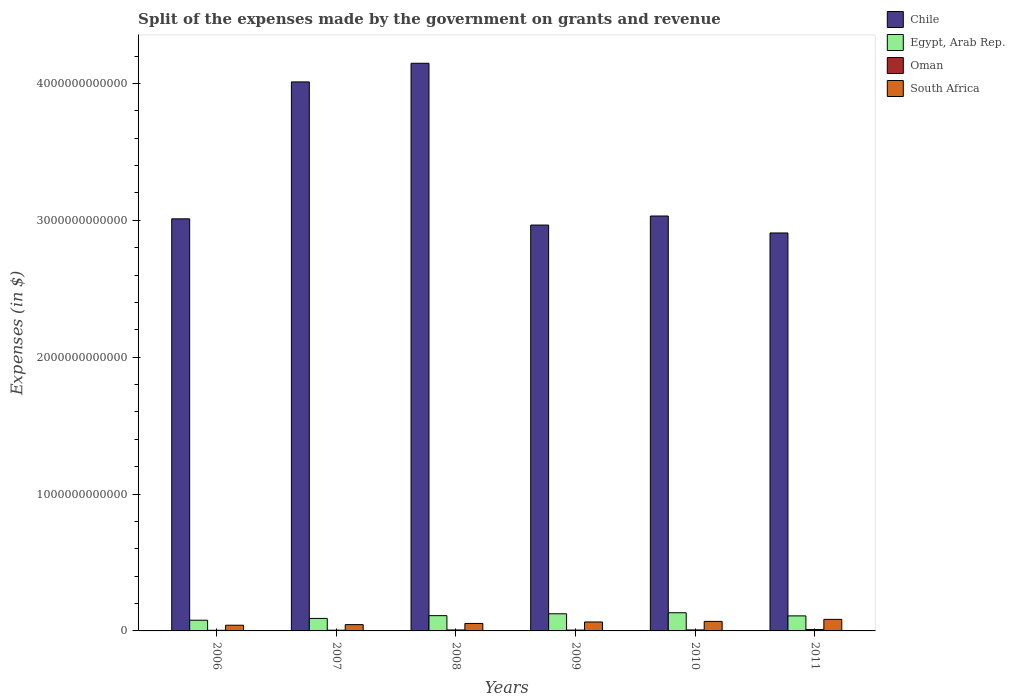How many different coloured bars are there?
Provide a succinct answer. 4. Are the number of bars per tick equal to the number of legend labels?
Provide a short and direct response. Yes. How many bars are there on the 1st tick from the left?
Provide a succinct answer. 4. How many bars are there on the 4th tick from the right?
Ensure brevity in your answer.  4. What is the label of the 2nd group of bars from the left?
Your answer should be very brief. 2007. In how many cases, is the number of bars for a given year not equal to the number of legend labels?
Keep it short and to the point. 0. What is the expenses made by the government on grants and revenue in Oman in 2008?
Offer a very short reply. 7.02e+09. Across all years, what is the maximum expenses made by the government on grants and revenue in Chile?
Ensure brevity in your answer.  4.15e+12. Across all years, what is the minimum expenses made by the government on grants and revenue in South Africa?
Provide a short and direct response. 4.16e+1. In which year was the expenses made by the government on grants and revenue in Chile maximum?
Give a very brief answer. 2008. In which year was the expenses made by the government on grants and revenue in Egypt, Arab Rep. minimum?
Provide a succinct answer. 2006. What is the total expenses made by the government on grants and revenue in Oman in the graph?
Offer a very short reply. 4.05e+1. What is the difference between the expenses made by the government on grants and revenue in South Africa in 2007 and that in 2010?
Provide a succinct answer. -2.36e+1. What is the difference between the expenses made by the government on grants and revenue in South Africa in 2008 and the expenses made by the government on grants and revenue in Egypt, Arab Rep. in 2011?
Your response must be concise. -5.53e+1. What is the average expenses made by the government on grants and revenue in Egypt, Arab Rep. per year?
Your answer should be very brief. 1.08e+11. In the year 2006, what is the difference between the expenses made by the government on grants and revenue in Egypt, Arab Rep. and expenses made by the government on grants and revenue in South Africa?
Offer a terse response. 3.66e+1. In how many years, is the expenses made by the government on grants and revenue in Egypt, Arab Rep. greater than 3600000000000 $?
Offer a terse response. 0. What is the ratio of the expenses made by the government on grants and revenue in Chile in 2010 to that in 2011?
Your response must be concise. 1.04. Is the expenses made by the government on grants and revenue in Chile in 2007 less than that in 2011?
Your answer should be compact. No. Is the difference between the expenses made by the government on grants and revenue in Egypt, Arab Rep. in 2010 and 2011 greater than the difference between the expenses made by the government on grants and revenue in South Africa in 2010 and 2011?
Keep it short and to the point. Yes. What is the difference between the highest and the second highest expenses made by the government on grants and revenue in Chile?
Your answer should be very brief. 1.36e+11. What is the difference between the highest and the lowest expenses made by the government on grants and revenue in South Africa?
Your response must be concise. 4.28e+1. Is the sum of the expenses made by the government on grants and revenue in Oman in 2008 and 2011 greater than the maximum expenses made by the government on grants and revenue in South Africa across all years?
Ensure brevity in your answer.  No. What does the 3rd bar from the left in 2007 represents?
Provide a short and direct response. Oman. Is it the case that in every year, the sum of the expenses made by the government on grants and revenue in South Africa and expenses made by the government on grants and revenue in Egypt, Arab Rep. is greater than the expenses made by the government on grants and revenue in Chile?
Give a very brief answer. No. How many bars are there?
Make the answer very short. 24. Are all the bars in the graph horizontal?
Provide a succinct answer. No. How many years are there in the graph?
Your answer should be very brief. 6. What is the difference between two consecutive major ticks on the Y-axis?
Make the answer very short. 1.00e+12. Are the values on the major ticks of Y-axis written in scientific E-notation?
Keep it short and to the point. No. Does the graph contain any zero values?
Ensure brevity in your answer.  No. Where does the legend appear in the graph?
Keep it short and to the point. Top right. How are the legend labels stacked?
Provide a short and direct response. Vertical. What is the title of the graph?
Provide a short and direct response. Split of the expenses made by the government on grants and revenue. What is the label or title of the X-axis?
Your answer should be very brief. Years. What is the label or title of the Y-axis?
Keep it short and to the point. Expenses (in $). What is the Expenses (in $) of Chile in 2006?
Provide a short and direct response. 3.01e+12. What is the Expenses (in $) in Egypt, Arab Rep. in 2006?
Keep it short and to the point. 7.82e+1. What is the Expenses (in $) of Oman in 2006?
Give a very brief answer. 4.63e+09. What is the Expenses (in $) in South Africa in 2006?
Your answer should be compact. 4.16e+1. What is the Expenses (in $) in Chile in 2007?
Provide a succinct answer. 4.01e+12. What is the Expenses (in $) in Egypt, Arab Rep. in 2007?
Provide a short and direct response. 9.13e+1. What is the Expenses (in $) in Oman in 2007?
Provide a succinct answer. 5.40e+09. What is the Expenses (in $) in South Africa in 2007?
Give a very brief answer. 4.60e+1. What is the Expenses (in $) in Chile in 2008?
Give a very brief answer. 4.15e+12. What is the Expenses (in $) of Egypt, Arab Rep. in 2008?
Ensure brevity in your answer.  1.12e+11. What is the Expenses (in $) in Oman in 2008?
Keep it short and to the point. 7.02e+09. What is the Expenses (in $) in South Africa in 2008?
Offer a terse response. 5.46e+1. What is the Expenses (in $) in Chile in 2009?
Make the answer very short. 2.97e+12. What is the Expenses (in $) of Egypt, Arab Rep. in 2009?
Your answer should be compact. 1.25e+11. What is the Expenses (in $) of Oman in 2009?
Your response must be concise. 6.14e+09. What is the Expenses (in $) in South Africa in 2009?
Make the answer very short. 6.53e+1. What is the Expenses (in $) of Chile in 2010?
Ensure brevity in your answer.  3.03e+12. What is the Expenses (in $) in Egypt, Arab Rep. in 2010?
Your answer should be very brief. 1.33e+11. What is the Expenses (in $) in Oman in 2010?
Make the answer very short. 7.31e+09. What is the Expenses (in $) in South Africa in 2010?
Provide a short and direct response. 6.96e+1. What is the Expenses (in $) in Chile in 2011?
Provide a succinct answer. 2.91e+12. What is the Expenses (in $) in Egypt, Arab Rep. in 2011?
Offer a terse response. 1.10e+11. What is the Expenses (in $) in Oman in 2011?
Make the answer very short. 9.99e+09. What is the Expenses (in $) in South Africa in 2011?
Offer a very short reply. 8.44e+1. Across all years, what is the maximum Expenses (in $) of Chile?
Offer a very short reply. 4.15e+12. Across all years, what is the maximum Expenses (in $) of Egypt, Arab Rep.?
Make the answer very short. 1.33e+11. Across all years, what is the maximum Expenses (in $) of Oman?
Offer a very short reply. 9.99e+09. Across all years, what is the maximum Expenses (in $) of South Africa?
Offer a very short reply. 8.44e+1. Across all years, what is the minimum Expenses (in $) in Chile?
Keep it short and to the point. 2.91e+12. Across all years, what is the minimum Expenses (in $) in Egypt, Arab Rep.?
Make the answer very short. 7.82e+1. Across all years, what is the minimum Expenses (in $) of Oman?
Give a very brief answer. 4.63e+09. Across all years, what is the minimum Expenses (in $) in South Africa?
Keep it short and to the point. 4.16e+1. What is the total Expenses (in $) of Chile in the graph?
Make the answer very short. 2.01e+13. What is the total Expenses (in $) of Egypt, Arab Rep. in the graph?
Provide a short and direct response. 6.49e+11. What is the total Expenses (in $) in Oman in the graph?
Give a very brief answer. 4.05e+1. What is the total Expenses (in $) of South Africa in the graph?
Your answer should be compact. 3.62e+11. What is the difference between the Expenses (in $) in Chile in 2006 and that in 2007?
Your answer should be very brief. -1.00e+12. What is the difference between the Expenses (in $) in Egypt, Arab Rep. in 2006 and that in 2007?
Your response must be concise. -1.32e+1. What is the difference between the Expenses (in $) in Oman in 2006 and that in 2007?
Make the answer very short. -7.66e+08. What is the difference between the Expenses (in $) of South Africa in 2006 and that in 2007?
Give a very brief answer. -4.43e+09. What is the difference between the Expenses (in $) of Chile in 2006 and that in 2008?
Give a very brief answer. -1.14e+12. What is the difference between the Expenses (in $) in Egypt, Arab Rep. in 2006 and that in 2008?
Your response must be concise. -3.35e+1. What is the difference between the Expenses (in $) of Oman in 2006 and that in 2008?
Your answer should be compact. -2.38e+09. What is the difference between the Expenses (in $) in South Africa in 2006 and that in 2008?
Your answer should be compact. -1.30e+1. What is the difference between the Expenses (in $) of Chile in 2006 and that in 2009?
Provide a short and direct response. 4.55e+1. What is the difference between the Expenses (in $) in Egypt, Arab Rep. in 2006 and that in 2009?
Your answer should be very brief. -4.72e+1. What is the difference between the Expenses (in $) of Oman in 2006 and that in 2009?
Your answer should be compact. -1.50e+09. What is the difference between the Expenses (in $) of South Africa in 2006 and that in 2009?
Your response must be concise. -2.37e+1. What is the difference between the Expenses (in $) in Chile in 2006 and that in 2010?
Your response must be concise. -2.07e+1. What is the difference between the Expenses (in $) in Egypt, Arab Rep. in 2006 and that in 2010?
Keep it short and to the point. -5.47e+1. What is the difference between the Expenses (in $) in Oman in 2006 and that in 2010?
Give a very brief answer. -2.67e+09. What is the difference between the Expenses (in $) in South Africa in 2006 and that in 2010?
Offer a very short reply. -2.80e+1. What is the difference between the Expenses (in $) in Chile in 2006 and that in 2011?
Your answer should be very brief. 1.03e+11. What is the difference between the Expenses (in $) in Egypt, Arab Rep. in 2006 and that in 2011?
Offer a terse response. -3.18e+1. What is the difference between the Expenses (in $) in Oman in 2006 and that in 2011?
Provide a short and direct response. -5.35e+09. What is the difference between the Expenses (in $) of South Africa in 2006 and that in 2011?
Provide a succinct answer. -4.28e+1. What is the difference between the Expenses (in $) of Chile in 2007 and that in 2008?
Offer a very short reply. -1.36e+11. What is the difference between the Expenses (in $) of Egypt, Arab Rep. in 2007 and that in 2008?
Give a very brief answer. -2.03e+1. What is the difference between the Expenses (in $) in Oman in 2007 and that in 2008?
Provide a short and direct response. -1.62e+09. What is the difference between the Expenses (in $) in South Africa in 2007 and that in 2008?
Give a very brief answer. -8.61e+09. What is the difference between the Expenses (in $) in Chile in 2007 and that in 2009?
Give a very brief answer. 1.05e+12. What is the difference between the Expenses (in $) of Egypt, Arab Rep. in 2007 and that in 2009?
Provide a succinct answer. -3.40e+1. What is the difference between the Expenses (in $) in Oman in 2007 and that in 2009?
Offer a terse response. -7.37e+08. What is the difference between the Expenses (in $) in South Africa in 2007 and that in 2009?
Your answer should be compact. -1.93e+1. What is the difference between the Expenses (in $) of Chile in 2007 and that in 2010?
Your response must be concise. 9.80e+11. What is the difference between the Expenses (in $) in Egypt, Arab Rep. in 2007 and that in 2010?
Provide a succinct answer. -4.16e+1. What is the difference between the Expenses (in $) of Oman in 2007 and that in 2010?
Give a very brief answer. -1.90e+09. What is the difference between the Expenses (in $) of South Africa in 2007 and that in 2010?
Your answer should be very brief. -2.36e+1. What is the difference between the Expenses (in $) in Chile in 2007 and that in 2011?
Make the answer very short. 1.10e+12. What is the difference between the Expenses (in $) in Egypt, Arab Rep. in 2007 and that in 2011?
Your response must be concise. -1.86e+1. What is the difference between the Expenses (in $) in Oman in 2007 and that in 2011?
Your answer should be very brief. -4.59e+09. What is the difference between the Expenses (in $) in South Africa in 2007 and that in 2011?
Make the answer very short. -3.84e+1. What is the difference between the Expenses (in $) of Chile in 2008 and that in 2009?
Offer a terse response. 1.18e+12. What is the difference between the Expenses (in $) of Egypt, Arab Rep. in 2008 and that in 2009?
Give a very brief answer. -1.37e+1. What is the difference between the Expenses (in $) in Oman in 2008 and that in 2009?
Give a very brief answer. 8.79e+08. What is the difference between the Expenses (in $) in South Africa in 2008 and that in 2009?
Your answer should be very brief. -1.07e+1. What is the difference between the Expenses (in $) of Chile in 2008 and that in 2010?
Your answer should be very brief. 1.12e+12. What is the difference between the Expenses (in $) of Egypt, Arab Rep. in 2008 and that in 2010?
Provide a short and direct response. -2.12e+1. What is the difference between the Expenses (in $) of Oman in 2008 and that in 2010?
Give a very brief answer. -2.88e+08. What is the difference between the Expenses (in $) in South Africa in 2008 and that in 2010?
Offer a very short reply. -1.50e+1. What is the difference between the Expenses (in $) of Chile in 2008 and that in 2011?
Your response must be concise. 1.24e+12. What is the difference between the Expenses (in $) in Egypt, Arab Rep. in 2008 and that in 2011?
Your response must be concise. 1.70e+09. What is the difference between the Expenses (in $) in Oman in 2008 and that in 2011?
Keep it short and to the point. -2.97e+09. What is the difference between the Expenses (in $) of South Africa in 2008 and that in 2011?
Provide a succinct answer. -2.98e+1. What is the difference between the Expenses (in $) in Chile in 2009 and that in 2010?
Your answer should be compact. -6.61e+1. What is the difference between the Expenses (in $) of Egypt, Arab Rep. in 2009 and that in 2010?
Give a very brief answer. -7.56e+09. What is the difference between the Expenses (in $) of Oman in 2009 and that in 2010?
Provide a short and direct response. -1.17e+09. What is the difference between the Expenses (in $) in South Africa in 2009 and that in 2010?
Your answer should be very brief. -4.27e+09. What is the difference between the Expenses (in $) of Chile in 2009 and that in 2011?
Make the answer very short. 5.78e+1. What is the difference between the Expenses (in $) of Egypt, Arab Rep. in 2009 and that in 2011?
Provide a short and direct response. 1.54e+1. What is the difference between the Expenses (in $) in Oman in 2009 and that in 2011?
Your answer should be very brief. -3.85e+09. What is the difference between the Expenses (in $) of South Africa in 2009 and that in 2011?
Make the answer very short. -1.91e+1. What is the difference between the Expenses (in $) in Chile in 2010 and that in 2011?
Ensure brevity in your answer.  1.24e+11. What is the difference between the Expenses (in $) of Egypt, Arab Rep. in 2010 and that in 2011?
Make the answer very short. 2.29e+1. What is the difference between the Expenses (in $) of Oman in 2010 and that in 2011?
Your response must be concise. -2.68e+09. What is the difference between the Expenses (in $) in South Africa in 2010 and that in 2011?
Provide a short and direct response. -1.48e+1. What is the difference between the Expenses (in $) of Chile in 2006 and the Expenses (in $) of Egypt, Arab Rep. in 2007?
Offer a very short reply. 2.92e+12. What is the difference between the Expenses (in $) in Chile in 2006 and the Expenses (in $) in Oman in 2007?
Provide a short and direct response. 3.01e+12. What is the difference between the Expenses (in $) of Chile in 2006 and the Expenses (in $) of South Africa in 2007?
Keep it short and to the point. 2.96e+12. What is the difference between the Expenses (in $) in Egypt, Arab Rep. in 2006 and the Expenses (in $) in Oman in 2007?
Provide a succinct answer. 7.28e+1. What is the difference between the Expenses (in $) in Egypt, Arab Rep. in 2006 and the Expenses (in $) in South Africa in 2007?
Give a very brief answer. 3.21e+1. What is the difference between the Expenses (in $) in Oman in 2006 and the Expenses (in $) in South Africa in 2007?
Provide a succinct answer. -4.14e+1. What is the difference between the Expenses (in $) of Chile in 2006 and the Expenses (in $) of Egypt, Arab Rep. in 2008?
Give a very brief answer. 2.90e+12. What is the difference between the Expenses (in $) of Chile in 2006 and the Expenses (in $) of Oman in 2008?
Give a very brief answer. 3.00e+12. What is the difference between the Expenses (in $) in Chile in 2006 and the Expenses (in $) in South Africa in 2008?
Your answer should be compact. 2.96e+12. What is the difference between the Expenses (in $) of Egypt, Arab Rep. in 2006 and the Expenses (in $) of Oman in 2008?
Your response must be concise. 7.11e+1. What is the difference between the Expenses (in $) of Egypt, Arab Rep. in 2006 and the Expenses (in $) of South Africa in 2008?
Offer a very short reply. 2.35e+1. What is the difference between the Expenses (in $) of Oman in 2006 and the Expenses (in $) of South Africa in 2008?
Offer a terse response. -5.00e+1. What is the difference between the Expenses (in $) in Chile in 2006 and the Expenses (in $) in Egypt, Arab Rep. in 2009?
Provide a succinct answer. 2.89e+12. What is the difference between the Expenses (in $) of Chile in 2006 and the Expenses (in $) of Oman in 2009?
Offer a very short reply. 3.00e+12. What is the difference between the Expenses (in $) of Chile in 2006 and the Expenses (in $) of South Africa in 2009?
Your answer should be compact. 2.95e+12. What is the difference between the Expenses (in $) of Egypt, Arab Rep. in 2006 and the Expenses (in $) of Oman in 2009?
Your answer should be compact. 7.20e+1. What is the difference between the Expenses (in $) of Egypt, Arab Rep. in 2006 and the Expenses (in $) of South Africa in 2009?
Ensure brevity in your answer.  1.28e+1. What is the difference between the Expenses (in $) in Oman in 2006 and the Expenses (in $) in South Africa in 2009?
Your response must be concise. -6.07e+1. What is the difference between the Expenses (in $) of Chile in 2006 and the Expenses (in $) of Egypt, Arab Rep. in 2010?
Offer a very short reply. 2.88e+12. What is the difference between the Expenses (in $) of Chile in 2006 and the Expenses (in $) of Oman in 2010?
Your answer should be compact. 3.00e+12. What is the difference between the Expenses (in $) of Chile in 2006 and the Expenses (in $) of South Africa in 2010?
Your answer should be compact. 2.94e+12. What is the difference between the Expenses (in $) of Egypt, Arab Rep. in 2006 and the Expenses (in $) of Oman in 2010?
Keep it short and to the point. 7.08e+1. What is the difference between the Expenses (in $) in Egypt, Arab Rep. in 2006 and the Expenses (in $) in South Africa in 2010?
Keep it short and to the point. 8.55e+09. What is the difference between the Expenses (in $) of Oman in 2006 and the Expenses (in $) of South Africa in 2010?
Keep it short and to the point. -6.50e+1. What is the difference between the Expenses (in $) of Chile in 2006 and the Expenses (in $) of Egypt, Arab Rep. in 2011?
Your answer should be compact. 2.90e+12. What is the difference between the Expenses (in $) of Chile in 2006 and the Expenses (in $) of Oman in 2011?
Make the answer very short. 3.00e+12. What is the difference between the Expenses (in $) in Chile in 2006 and the Expenses (in $) in South Africa in 2011?
Keep it short and to the point. 2.93e+12. What is the difference between the Expenses (in $) of Egypt, Arab Rep. in 2006 and the Expenses (in $) of Oman in 2011?
Make the answer very short. 6.82e+1. What is the difference between the Expenses (in $) in Egypt, Arab Rep. in 2006 and the Expenses (in $) in South Africa in 2011?
Make the answer very short. -6.24e+09. What is the difference between the Expenses (in $) in Oman in 2006 and the Expenses (in $) in South Africa in 2011?
Give a very brief answer. -7.98e+1. What is the difference between the Expenses (in $) of Chile in 2007 and the Expenses (in $) of Egypt, Arab Rep. in 2008?
Your answer should be very brief. 3.90e+12. What is the difference between the Expenses (in $) of Chile in 2007 and the Expenses (in $) of Oman in 2008?
Your response must be concise. 4.00e+12. What is the difference between the Expenses (in $) of Chile in 2007 and the Expenses (in $) of South Africa in 2008?
Offer a terse response. 3.96e+12. What is the difference between the Expenses (in $) of Egypt, Arab Rep. in 2007 and the Expenses (in $) of Oman in 2008?
Your answer should be very brief. 8.43e+1. What is the difference between the Expenses (in $) in Egypt, Arab Rep. in 2007 and the Expenses (in $) in South Africa in 2008?
Give a very brief answer. 3.67e+1. What is the difference between the Expenses (in $) in Oman in 2007 and the Expenses (in $) in South Africa in 2008?
Provide a succinct answer. -4.92e+1. What is the difference between the Expenses (in $) in Chile in 2007 and the Expenses (in $) in Egypt, Arab Rep. in 2009?
Your response must be concise. 3.89e+12. What is the difference between the Expenses (in $) in Chile in 2007 and the Expenses (in $) in Oman in 2009?
Offer a very short reply. 4.01e+12. What is the difference between the Expenses (in $) in Chile in 2007 and the Expenses (in $) in South Africa in 2009?
Make the answer very short. 3.95e+12. What is the difference between the Expenses (in $) of Egypt, Arab Rep. in 2007 and the Expenses (in $) of Oman in 2009?
Provide a succinct answer. 8.52e+1. What is the difference between the Expenses (in $) of Egypt, Arab Rep. in 2007 and the Expenses (in $) of South Africa in 2009?
Provide a short and direct response. 2.60e+1. What is the difference between the Expenses (in $) of Oman in 2007 and the Expenses (in $) of South Africa in 2009?
Your response must be concise. -5.99e+1. What is the difference between the Expenses (in $) in Chile in 2007 and the Expenses (in $) in Egypt, Arab Rep. in 2010?
Your answer should be compact. 3.88e+12. What is the difference between the Expenses (in $) of Chile in 2007 and the Expenses (in $) of Oman in 2010?
Your answer should be compact. 4.00e+12. What is the difference between the Expenses (in $) of Chile in 2007 and the Expenses (in $) of South Africa in 2010?
Give a very brief answer. 3.94e+12. What is the difference between the Expenses (in $) in Egypt, Arab Rep. in 2007 and the Expenses (in $) in Oman in 2010?
Your response must be concise. 8.40e+1. What is the difference between the Expenses (in $) of Egypt, Arab Rep. in 2007 and the Expenses (in $) of South Africa in 2010?
Offer a terse response. 2.17e+1. What is the difference between the Expenses (in $) of Oman in 2007 and the Expenses (in $) of South Africa in 2010?
Your answer should be very brief. -6.42e+1. What is the difference between the Expenses (in $) in Chile in 2007 and the Expenses (in $) in Egypt, Arab Rep. in 2011?
Your answer should be very brief. 3.90e+12. What is the difference between the Expenses (in $) of Chile in 2007 and the Expenses (in $) of Oman in 2011?
Provide a succinct answer. 4.00e+12. What is the difference between the Expenses (in $) of Chile in 2007 and the Expenses (in $) of South Africa in 2011?
Ensure brevity in your answer.  3.93e+12. What is the difference between the Expenses (in $) of Egypt, Arab Rep. in 2007 and the Expenses (in $) of Oman in 2011?
Provide a succinct answer. 8.13e+1. What is the difference between the Expenses (in $) of Egypt, Arab Rep. in 2007 and the Expenses (in $) of South Africa in 2011?
Provide a succinct answer. 6.94e+09. What is the difference between the Expenses (in $) of Oman in 2007 and the Expenses (in $) of South Africa in 2011?
Provide a succinct answer. -7.90e+1. What is the difference between the Expenses (in $) in Chile in 2008 and the Expenses (in $) in Egypt, Arab Rep. in 2009?
Your response must be concise. 4.02e+12. What is the difference between the Expenses (in $) in Chile in 2008 and the Expenses (in $) in Oman in 2009?
Your response must be concise. 4.14e+12. What is the difference between the Expenses (in $) of Chile in 2008 and the Expenses (in $) of South Africa in 2009?
Offer a terse response. 4.08e+12. What is the difference between the Expenses (in $) in Egypt, Arab Rep. in 2008 and the Expenses (in $) in Oman in 2009?
Ensure brevity in your answer.  1.06e+11. What is the difference between the Expenses (in $) of Egypt, Arab Rep. in 2008 and the Expenses (in $) of South Africa in 2009?
Ensure brevity in your answer.  4.63e+1. What is the difference between the Expenses (in $) in Oman in 2008 and the Expenses (in $) in South Africa in 2009?
Your answer should be very brief. -5.83e+1. What is the difference between the Expenses (in $) of Chile in 2008 and the Expenses (in $) of Egypt, Arab Rep. in 2010?
Keep it short and to the point. 4.01e+12. What is the difference between the Expenses (in $) of Chile in 2008 and the Expenses (in $) of Oman in 2010?
Offer a terse response. 4.14e+12. What is the difference between the Expenses (in $) of Chile in 2008 and the Expenses (in $) of South Africa in 2010?
Your response must be concise. 4.08e+12. What is the difference between the Expenses (in $) of Egypt, Arab Rep. in 2008 and the Expenses (in $) of Oman in 2010?
Keep it short and to the point. 1.04e+11. What is the difference between the Expenses (in $) of Egypt, Arab Rep. in 2008 and the Expenses (in $) of South Africa in 2010?
Your answer should be very brief. 4.20e+1. What is the difference between the Expenses (in $) in Oman in 2008 and the Expenses (in $) in South Africa in 2010?
Offer a terse response. -6.26e+1. What is the difference between the Expenses (in $) of Chile in 2008 and the Expenses (in $) of Egypt, Arab Rep. in 2011?
Your answer should be very brief. 4.04e+12. What is the difference between the Expenses (in $) of Chile in 2008 and the Expenses (in $) of Oman in 2011?
Your answer should be compact. 4.14e+12. What is the difference between the Expenses (in $) of Chile in 2008 and the Expenses (in $) of South Africa in 2011?
Your answer should be compact. 4.06e+12. What is the difference between the Expenses (in $) in Egypt, Arab Rep. in 2008 and the Expenses (in $) in Oman in 2011?
Make the answer very short. 1.02e+11. What is the difference between the Expenses (in $) in Egypt, Arab Rep. in 2008 and the Expenses (in $) in South Africa in 2011?
Give a very brief answer. 2.73e+1. What is the difference between the Expenses (in $) of Oman in 2008 and the Expenses (in $) of South Africa in 2011?
Offer a very short reply. -7.74e+1. What is the difference between the Expenses (in $) of Chile in 2009 and the Expenses (in $) of Egypt, Arab Rep. in 2010?
Offer a terse response. 2.83e+12. What is the difference between the Expenses (in $) in Chile in 2009 and the Expenses (in $) in Oman in 2010?
Your answer should be compact. 2.96e+12. What is the difference between the Expenses (in $) in Chile in 2009 and the Expenses (in $) in South Africa in 2010?
Provide a succinct answer. 2.90e+12. What is the difference between the Expenses (in $) in Egypt, Arab Rep. in 2009 and the Expenses (in $) in Oman in 2010?
Offer a terse response. 1.18e+11. What is the difference between the Expenses (in $) of Egypt, Arab Rep. in 2009 and the Expenses (in $) of South Africa in 2010?
Your answer should be compact. 5.57e+1. What is the difference between the Expenses (in $) of Oman in 2009 and the Expenses (in $) of South Africa in 2010?
Your answer should be compact. -6.35e+1. What is the difference between the Expenses (in $) in Chile in 2009 and the Expenses (in $) in Egypt, Arab Rep. in 2011?
Ensure brevity in your answer.  2.86e+12. What is the difference between the Expenses (in $) in Chile in 2009 and the Expenses (in $) in Oman in 2011?
Offer a very short reply. 2.96e+12. What is the difference between the Expenses (in $) in Chile in 2009 and the Expenses (in $) in South Africa in 2011?
Give a very brief answer. 2.88e+12. What is the difference between the Expenses (in $) of Egypt, Arab Rep. in 2009 and the Expenses (in $) of Oman in 2011?
Your answer should be compact. 1.15e+11. What is the difference between the Expenses (in $) in Egypt, Arab Rep. in 2009 and the Expenses (in $) in South Africa in 2011?
Your answer should be very brief. 4.09e+1. What is the difference between the Expenses (in $) in Oman in 2009 and the Expenses (in $) in South Africa in 2011?
Make the answer very short. -7.82e+1. What is the difference between the Expenses (in $) in Chile in 2010 and the Expenses (in $) in Egypt, Arab Rep. in 2011?
Your answer should be very brief. 2.92e+12. What is the difference between the Expenses (in $) of Chile in 2010 and the Expenses (in $) of Oman in 2011?
Offer a very short reply. 3.02e+12. What is the difference between the Expenses (in $) in Chile in 2010 and the Expenses (in $) in South Africa in 2011?
Your response must be concise. 2.95e+12. What is the difference between the Expenses (in $) in Egypt, Arab Rep. in 2010 and the Expenses (in $) in Oman in 2011?
Offer a terse response. 1.23e+11. What is the difference between the Expenses (in $) in Egypt, Arab Rep. in 2010 and the Expenses (in $) in South Africa in 2011?
Ensure brevity in your answer.  4.85e+1. What is the difference between the Expenses (in $) of Oman in 2010 and the Expenses (in $) of South Africa in 2011?
Your response must be concise. -7.71e+1. What is the average Expenses (in $) of Chile per year?
Your answer should be compact. 3.35e+12. What is the average Expenses (in $) in Egypt, Arab Rep. per year?
Your response must be concise. 1.08e+11. What is the average Expenses (in $) of Oman per year?
Ensure brevity in your answer.  6.75e+09. What is the average Expenses (in $) in South Africa per year?
Ensure brevity in your answer.  6.03e+1. In the year 2006, what is the difference between the Expenses (in $) of Chile and Expenses (in $) of Egypt, Arab Rep.?
Offer a very short reply. 2.93e+12. In the year 2006, what is the difference between the Expenses (in $) in Chile and Expenses (in $) in Oman?
Provide a short and direct response. 3.01e+12. In the year 2006, what is the difference between the Expenses (in $) of Chile and Expenses (in $) of South Africa?
Provide a short and direct response. 2.97e+12. In the year 2006, what is the difference between the Expenses (in $) in Egypt, Arab Rep. and Expenses (in $) in Oman?
Keep it short and to the point. 7.35e+1. In the year 2006, what is the difference between the Expenses (in $) in Egypt, Arab Rep. and Expenses (in $) in South Africa?
Your answer should be very brief. 3.66e+1. In the year 2006, what is the difference between the Expenses (in $) of Oman and Expenses (in $) of South Africa?
Make the answer very short. -3.69e+1. In the year 2007, what is the difference between the Expenses (in $) of Chile and Expenses (in $) of Egypt, Arab Rep.?
Offer a terse response. 3.92e+12. In the year 2007, what is the difference between the Expenses (in $) in Chile and Expenses (in $) in Oman?
Provide a succinct answer. 4.01e+12. In the year 2007, what is the difference between the Expenses (in $) of Chile and Expenses (in $) of South Africa?
Provide a short and direct response. 3.97e+12. In the year 2007, what is the difference between the Expenses (in $) in Egypt, Arab Rep. and Expenses (in $) in Oman?
Provide a short and direct response. 8.59e+1. In the year 2007, what is the difference between the Expenses (in $) of Egypt, Arab Rep. and Expenses (in $) of South Africa?
Your answer should be compact. 4.53e+1. In the year 2007, what is the difference between the Expenses (in $) of Oman and Expenses (in $) of South Africa?
Give a very brief answer. -4.06e+1. In the year 2008, what is the difference between the Expenses (in $) of Chile and Expenses (in $) of Egypt, Arab Rep.?
Keep it short and to the point. 4.04e+12. In the year 2008, what is the difference between the Expenses (in $) in Chile and Expenses (in $) in Oman?
Offer a very short reply. 4.14e+12. In the year 2008, what is the difference between the Expenses (in $) of Chile and Expenses (in $) of South Africa?
Ensure brevity in your answer.  4.09e+12. In the year 2008, what is the difference between the Expenses (in $) in Egypt, Arab Rep. and Expenses (in $) in Oman?
Ensure brevity in your answer.  1.05e+11. In the year 2008, what is the difference between the Expenses (in $) of Egypt, Arab Rep. and Expenses (in $) of South Africa?
Ensure brevity in your answer.  5.70e+1. In the year 2008, what is the difference between the Expenses (in $) of Oman and Expenses (in $) of South Africa?
Keep it short and to the point. -4.76e+1. In the year 2009, what is the difference between the Expenses (in $) in Chile and Expenses (in $) in Egypt, Arab Rep.?
Your answer should be very brief. 2.84e+12. In the year 2009, what is the difference between the Expenses (in $) of Chile and Expenses (in $) of Oman?
Provide a short and direct response. 2.96e+12. In the year 2009, what is the difference between the Expenses (in $) of Chile and Expenses (in $) of South Africa?
Ensure brevity in your answer.  2.90e+12. In the year 2009, what is the difference between the Expenses (in $) in Egypt, Arab Rep. and Expenses (in $) in Oman?
Make the answer very short. 1.19e+11. In the year 2009, what is the difference between the Expenses (in $) in Egypt, Arab Rep. and Expenses (in $) in South Africa?
Make the answer very short. 6.00e+1. In the year 2009, what is the difference between the Expenses (in $) in Oman and Expenses (in $) in South Africa?
Your answer should be compact. -5.92e+1. In the year 2010, what is the difference between the Expenses (in $) in Chile and Expenses (in $) in Egypt, Arab Rep.?
Ensure brevity in your answer.  2.90e+12. In the year 2010, what is the difference between the Expenses (in $) in Chile and Expenses (in $) in Oman?
Give a very brief answer. 3.02e+12. In the year 2010, what is the difference between the Expenses (in $) in Chile and Expenses (in $) in South Africa?
Offer a very short reply. 2.96e+12. In the year 2010, what is the difference between the Expenses (in $) in Egypt, Arab Rep. and Expenses (in $) in Oman?
Make the answer very short. 1.26e+11. In the year 2010, what is the difference between the Expenses (in $) of Egypt, Arab Rep. and Expenses (in $) of South Africa?
Your answer should be compact. 6.33e+1. In the year 2010, what is the difference between the Expenses (in $) of Oman and Expenses (in $) of South Africa?
Offer a very short reply. -6.23e+1. In the year 2011, what is the difference between the Expenses (in $) of Chile and Expenses (in $) of Egypt, Arab Rep.?
Make the answer very short. 2.80e+12. In the year 2011, what is the difference between the Expenses (in $) in Chile and Expenses (in $) in Oman?
Your response must be concise. 2.90e+12. In the year 2011, what is the difference between the Expenses (in $) in Chile and Expenses (in $) in South Africa?
Your answer should be very brief. 2.82e+12. In the year 2011, what is the difference between the Expenses (in $) of Egypt, Arab Rep. and Expenses (in $) of Oman?
Keep it short and to the point. 9.99e+1. In the year 2011, what is the difference between the Expenses (in $) of Egypt, Arab Rep. and Expenses (in $) of South Africa?
Make the answer very short. 2.56e+1. In the year 2011, what is the difference between the Expenses (in $) in Oman and Expenses (in $) in South Africa?
Offer a terse response. -7.44e+1. What is the ratio of the Expenses (in $) in Chile in 2006 to that in 2007?
Your response must be concise. 0.75. What is the ratio of the Expenses (in $) of Egypt, Arab Rep. in 2006 to that in 2007?
Provide a succinct answer. 0.86. What is the ratio of the Expenses (in $) of Oman in 2006 to that in 2007?
Offer a very short reply. 0.86. What is the ratio of the Expenses (in $) in South Africa in 2006 to that in 2007?
Make the answer very short. 0.9. What is the ratio of the Expenses (in $) of Chile in 2006 to that in 2008?
Offer a terse response. 0.73. What is the ratio of the Expenses (in $) of Egypt, Arab Rep. in 2006 to that in 2008?
Provide a short and direct response. 0.7. What is the ratio of the Expenses (in $) of Oman in 2006 to that in 2008?
Offer a very short reply. 0.66. What is the ratio of the Expenses (in $) in South Africa in 2006 to that in 2008?
Offer a very short reply. 0.76. What is the ratio of the Expenses (in $) in Chile in 2006 to that in 2009?
Offer a terse response. 1.02. What is the ratio of the Expenses (in $) of Egypt, Arab Rep. in 2006 to that in 2009?
Give a very brief answer. 0.62. What is the ratio of the Expenses (in $) in Oman in 2006 to that in 2009?
Your response must be concise. 0.76. What is the ratio of the Expenses (in $) of South Africa in 2006 to that in 2009?
Make the answer very short. 0.64. What is the ratio of the Expenses (in $) in Chile in 2006 to that in 2010?
Your response must be concise. 0.99. What is the ratio of the Expenses (in $) of Egypt, Arab Rep. in 2006 to that in 2010?
Give a very brief answer. 0.59. What is the ratio of the Expenses (in $) in Oman in 2006 to that in 2010?
Provide a succinct answer. 0.63. What is the ratio of the Expenses (in $) of South Africa in 2006 to that in 2010?
Your answer should be very brief. 0.6. What is the ratio of the Expenses (in $) in Chile in 2006 to that in 2011?
Your answer should be compact. 1.04. What is the ratio of the Expenses (in $) in Egypt, Arab Rep. in 2006 to that in 2011?
Give a very brief answer. 0.71. What is the ratio of the Expenses (in $) in Oman in 2006 to that in 2011?
Your response must be concise. 0.46. What is the ratio of the Expenses (in $) of South Africa in 2006 to that in 2011?
Offer a terse response. 0.49. What is the ratio of the Expenses (in $) in Chile in 2007 to that in 2008?
Provide a succinct answer. 0.97. What is the ratio of the Expenses (in $) of Egypt, Arab Rep. in 2007 to that in 2008?
Your answer should be compact. 0.82. What is the ratio of the Expenses (in $) of Oman in 2007 to that in 2008?
Ensure brevity in your answer.  0.77. What is the ratio of the Expenses (in $) of South Africa in 2007 to that in 2008?
Give a very brief answer. 0.84. What is the ratio of the Expenses (in $) in Chile in 2007 to that in 2009?
Offer a terse response. 1.35. What is the ratio of the Expenses (in $) in Egypt, Arab Rep. in 2007 to that in 2009?
Your response must be concise. 0.73. What is the ratio of the Expenses (in $) of Oman in 2007 to that in 2009?
Offer a very short reply. 0.88. What is the ratio of the Expenses (in $) in South Africa in 2007 to that in 2009?
Your answer should be compact. 0.7. What is the ratio of the Expenses (in $) of Chile in 2007 to that in 2010?
Make the answer very short. 1.32. What is the ratio of the Expenses (in $) of Egypt, Arab Rep. in 2007 to that in 2010?
Ensure brevity in your answer.  0.69. What is the ratio of the Expenses (in $) in Oman in 2007 to that in 2010?
Make the answer very short. 0.74. What is the ratio of the Expenses (in $) of South Africa in 2007 to that in 2010?
Make the answer very short. 0.66. What is the ratio of the Expenses (in $) of Chile in 2007 to that in 2011?
Your answer should be compact. 1.38. What is the ratio of the Expenses (in $) in Egypt, Arab Rep. in 2007 to that in 2011?
Provide a succinct answer. 0.83. What is the ratio of the Expenses (in $) in Oman in 2007 to that in 2011?
Provide a succinct answer. 0.54. What is the ratio of the Expenses (in $) of South Africa in 2007 to that in 2011?
Provide a short and direct response. 0.55. What is the ratio of the Expenses (in $) of Chile in 2008 to that in 2009?
Your answer should be compact. 1.4. What is the ratio of the Expenses (in $) in Egypt, Arab Rep. in 2008 to that in 2009?
Give a very brief answer. 0.89. What is the ratio of the Expenses (in $) in Oman in 2008 to that in 2009?
Keep it short and to the point. 1.14. What is the ratio of the Expenses (in $) of South Africa in 2008 to that in 2009?
Your answer should be compact. 0.84. What is the ratio of the Expenses (in $) in Chile in 2008 to that in 2010?
Offer a terse response. 1.37. What is the ratio of the Expenses (in $) of Egypt, Arab Rep. in 2008 to that in 2010?
Offer a terse response. 0.84. What is the ratio of the Expenses (in $) in Oman in 2008 to that in 2010?
Offer a very short reply. 0.96. What is the ratio of the Expenses (in $) in South Africa in 2008 to that in 2010?
Ensure brevity in your answer.  0.78. What is the ratio of the Expenses (in $) of Chile in 2008 to that in 2011?
Offer a terse response. 1.43. What is the ratio of the Expenses (in $) of Egypt, Arab Rep. in 2008 to that in 2011?
Offer a very short reply. 1.02. What is the ratio of the Expenses (in $) of Oman in 2008 to that in 2011?
Offer a very short reply. 0.7. What is the ratio of the Expenses (in $) in South Africa in 2008 to that in 2011?
Offer a terse response. 0.65. What is the ratio of the Expenses (in $) in Chile in 2009 to that in 2010?
Ensure brevity in your answer.  0.98. What is the ratio of the Expenses (in $) of Egypt, Arab Rep. in 2009 to that in 2010?
Your answer should be compact. 0.94. What is the ratio of the Expenses (in $) of Oman in 2009 to that in 2010?
Provide a succinct answer. 0.84. What is the ratio of the Expenses (in $) of South Africa in 2009 to that in 2010?
Provide a short and direct response. 0.94. What is the ratio of the Expenses (in $) in Chile in 2009 to that in 2011?
Your answer should be compact. 1.02. What is the ratio of the Expenses (in $) in Egypt, Arab Rep. in 2009 to that in 2011?
Keep it short and to the point. 1.14. What is the ratio of the Expenses (in $) of Oman in 2009 to that in 2011?
Your response must be concise. 0.61. What is the ratio of the Expenses (in $) in South Africa in 2009 to that in 2011?
Give a very brief answer. 0.77. What is the ratio of the Expenses (in $) of Chile in 2010 to that in 2011?
Your response must be concise. 1.04. What is the ratio of the Expenses (in $) in Egypt, Arab Rep. in 2010 to that in 2011?
Offer a terse response. 1.21. What is the ratio of the Expenses (in $) of Oman in 2010 to that in 2011?
Provide a short and direct response. 0.73. What is the ratio of the Expenses (in $) of South Africa in 2010 to that in 2011?
Give a very brief answer. 0.82. What is the difference between the highest and the second highest Expenses (in $) of Chile?
Your answer should be compact. 1.36e+11. What is the difference between the highest and the second highest Expenses (in $) in Egypt, Arab Rep.?
Give a very brief answer. 7.56e+09. What is the difference between the highest and the second highest Expenses (in $) of Oman?
Give a very brief answer. 2.68e+09. What is the difference between the highest and the second highest Expenses (in $) in South Africa?
Ensure brevity in your answer.  1.48e+1. What is the difference between the highest and the lowest Expenses (in $) of Chile?
Keep it short and to the point. 1.24e+12. What is the difference between the highest and the lowest Expenses (in $) of Egypt, Arab Rep.?
Your response must be concise. 5.47e+1. What is the difference between the highest and the lowest Expenses (in $) in Oman?
Offer a terse response. 5.35e+09. What is the difference between the highest and the lowest Expenses (in $) in South Africa?
Offer a terse response. 4.28e+1. 